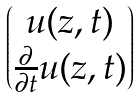<formula> <loc_0><loc_0><loc_500><loc_500>\begin{pmatrix} u ( z , t ) \\ \frac { \partial } { \partial t } u ( z , t ) \end{pmatrix}</formula> 